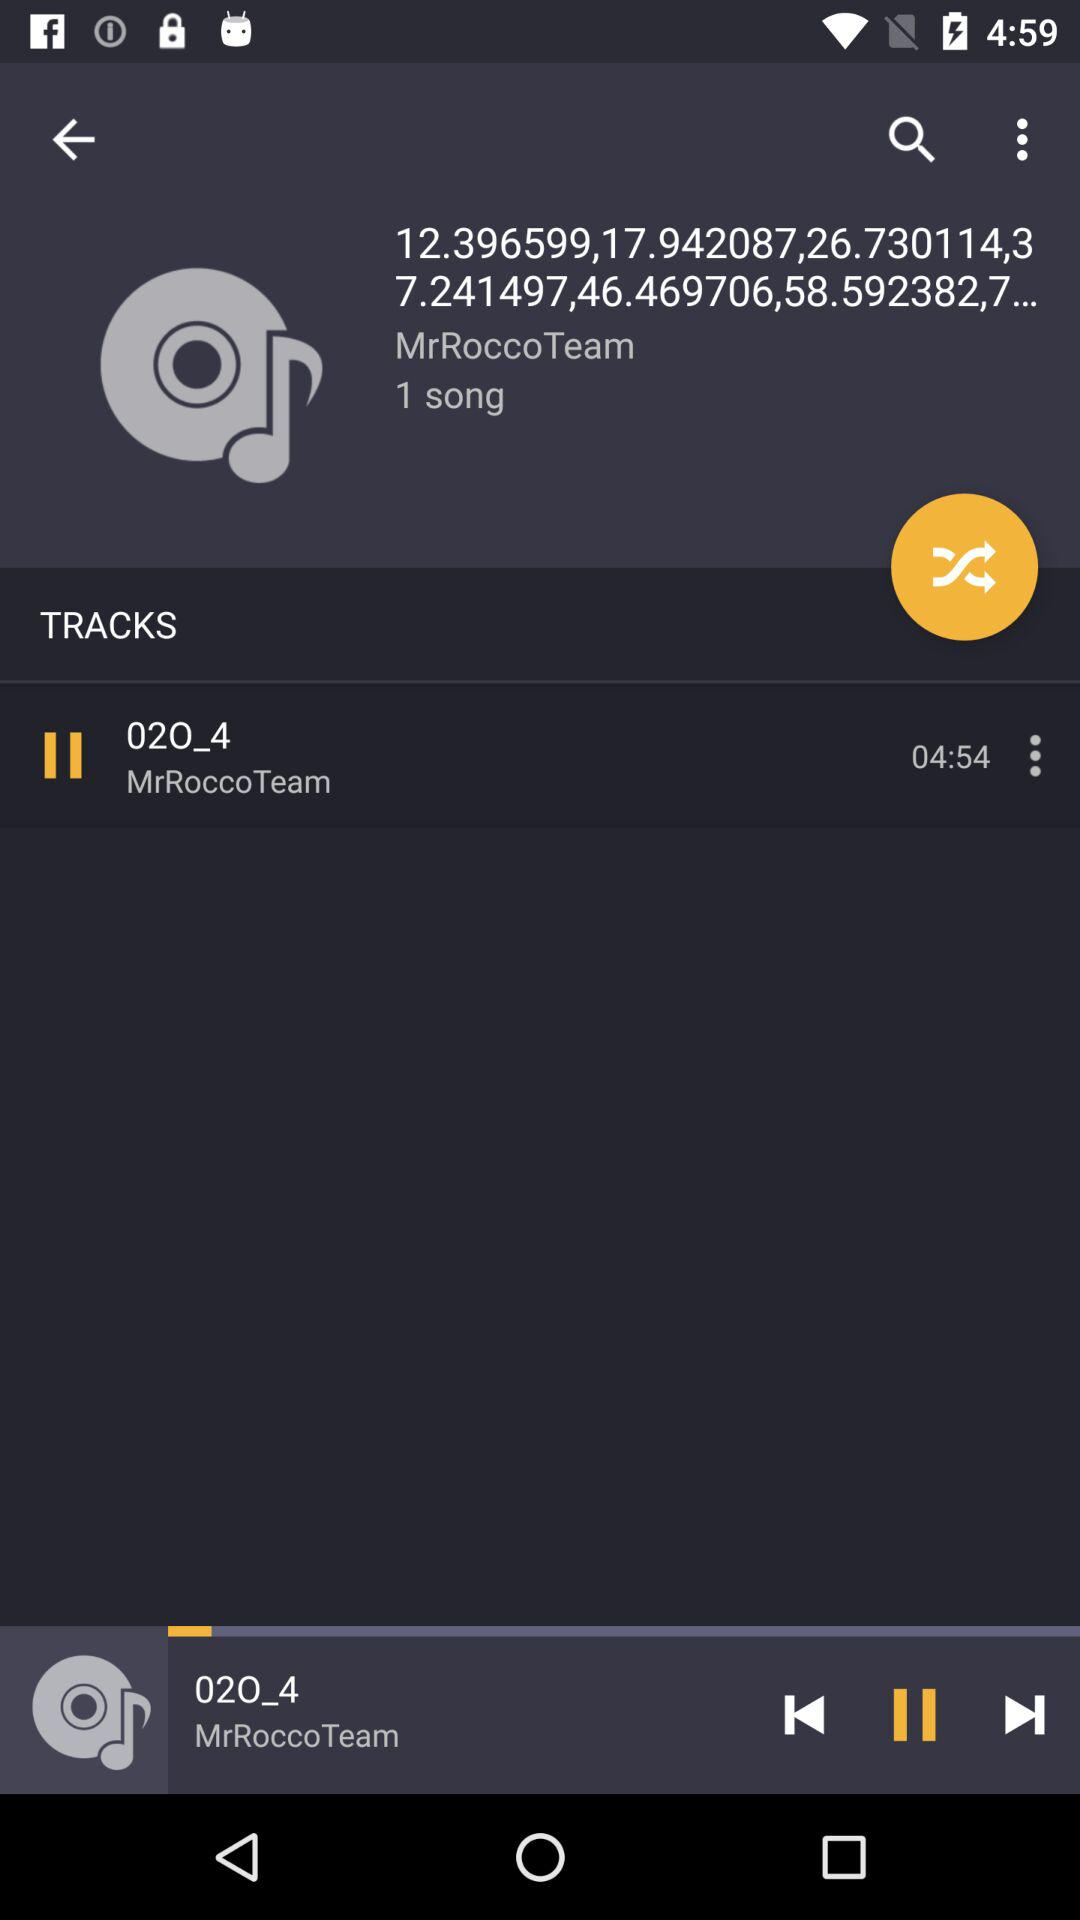How many songs are there?
Answer the question using a single word or phrase. 1 